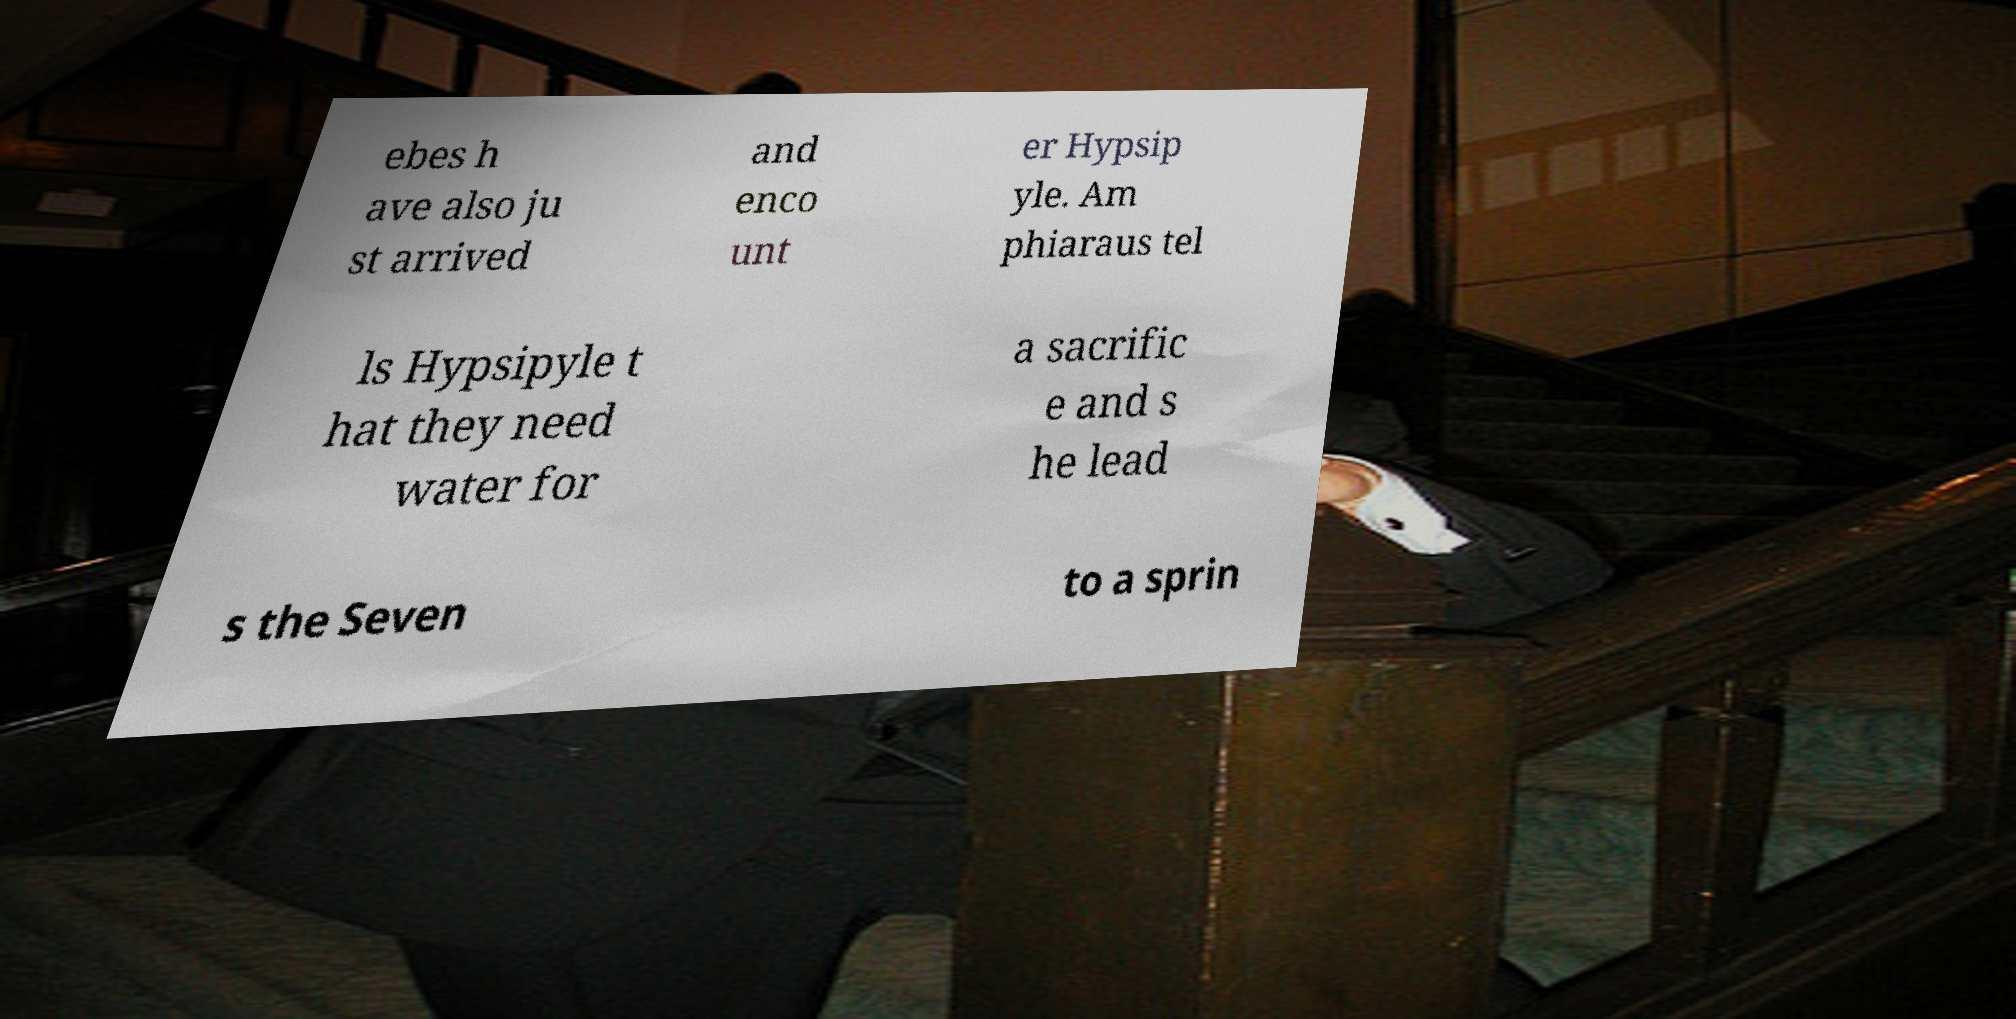I need the written content from this picture converted into text. Can you do that? ebes h ave also ju st arrived and enco unt er Hypsip yle. Am phiaraus tel ls Hypsipyle t hat they need water for a sacrific e and s he lead s the Seven to a sprin 